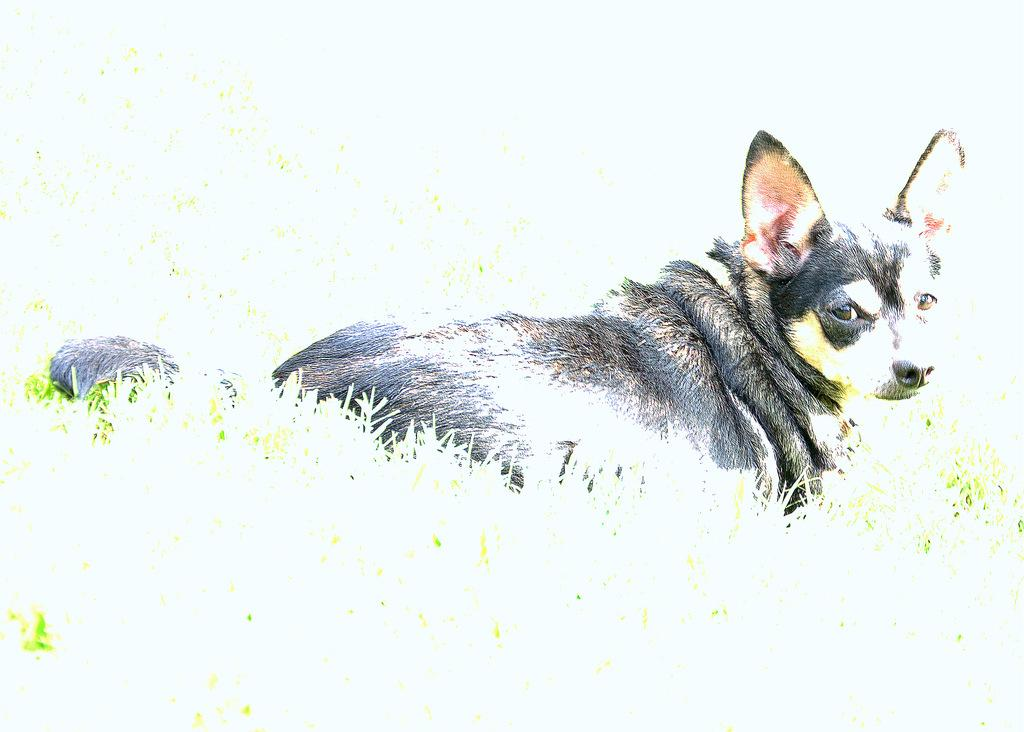What type of animal is in the image? There is a dog in the image. What color is the dog in the image? The dog is in black and white color. What type of surface is visible in the image? There is grass visible in the image. What color is the background of the image? The background of the image is white. What type of paper is the writer using to write in the image? There is no paper or writer present in the image; it features a dog in black and white color with grass and a white background. 